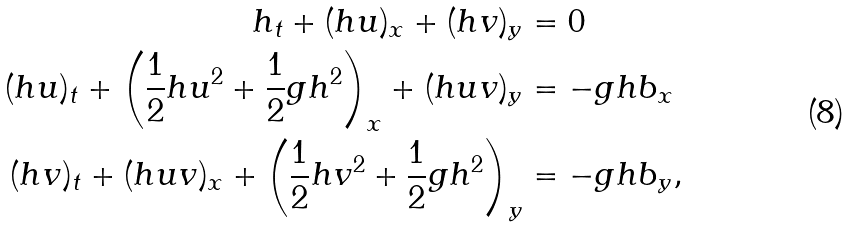<formula> <loc_0><loc_0><loc_500><loc_500>h _ { t } + ( h u ) _ { x } + ( h v ) _ { y } & = 0 \\ ( h u ) _ { t } + \left ( \frac { 1 } { 2 } h u ^ { 2 } + \frac { 1 } { 2 } g h ^ { 2 } \right ) _ { x } + ( h u v ) _ { y } & = - g h b _ { x } \\ ( h v ) _ { t } + ( h u v ) _ { x } + \left ( \frac { 1 } { 2 } h v ^ { 2 } + \frac { 1 } { 2 } g h ^ { 2 } \right ) _ { y } & = - g h b _ { y } ,</formula> 